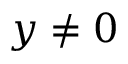Convert formula to latex. <formula><loc_0><loc_0><loc_500><loc_500>y \neq 0</formula> 